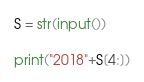<code> <loc_0><loc_0><loc_500><loc_500><_Python_>S = str(input())

print("2018"+S[4:])</code> 